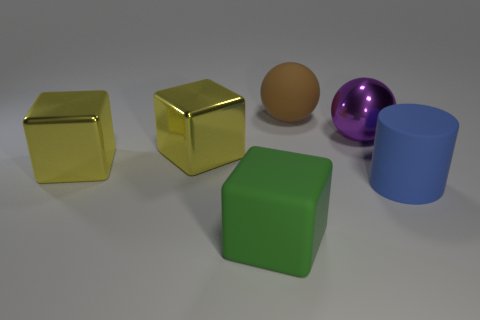Add 4 tiny yellow spheres. How many objects exist? 10 Subtract all cylinders. How many objects are left? 5 Add 4 purple metallic spheres. How many purple metallic spheres exist? 5 Subtract 0 blue balls. How many objects are left? 6 Subtract all metallic cubes. Subtract all big blue objects. How many objects are left? 3 Add 2 big things. How many big things are left? 8 